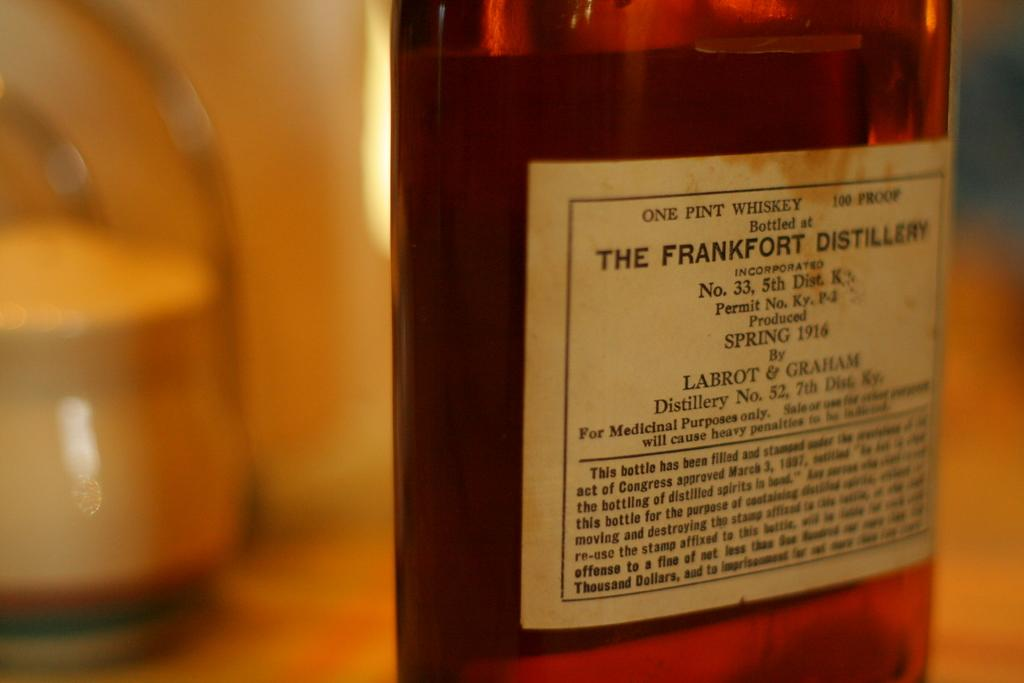<image>
Describe the image concisely. A bottle of of whiskey that was produced in 1916. 